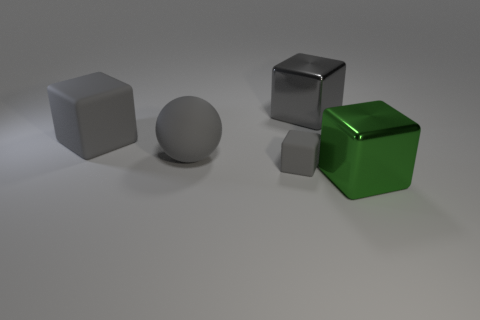What shape is the small thing that is the same color as the rubber ball?
Your answer should be very brief. Cube. What is the material of the large sphere that is the same color as the tiny matte cube?
Keep it short and to the point. Rubber. There is a big cube that is on the left side of the tiny gray cube; is it the same color as the big ball?
Offer a very short reply. Yes. There is a big metallic object that is behind the small gray thing; is its color the same as the big rubber cube that is left of the big green metal object?
Your response must be concise. Yes. Are there any large gray rubber objects that have the same shape as the green metallic object?
Make the answer very short. Yes. What material is the big cube to the left of the metal object that is to the left of the big cube that is in front of the gray matte ball made of?
Provide a succinct answer. Rubber. Are there any other things of the same size as the green metallic thing?
Offer a terse response. Yes. What color is the metallic thing that is behind the big thing in front of the small gray rubber thing?
Provide a succinct answer. Gray. What number of large gray blocks are there?
Ensure brevity in your answer.  2. Does the small matte object have the same color as the big rubber ball?
Provide a short and direct response. Yes. 